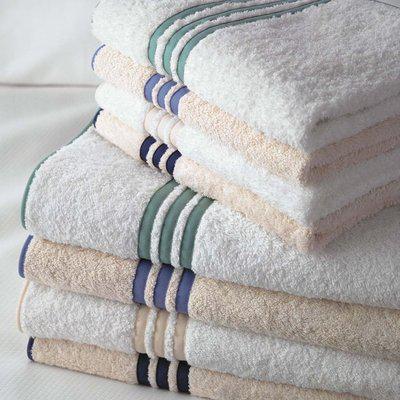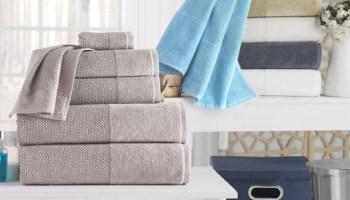The first image is the image on the left, the second image is the image on the right. Given the left and right images, does the statement "There are towels hanging on racks." hold true? Answer yes or no. No. The first image is the image on the left, the second image is the image on the right. Examine the images to the left and right. Is the description "A light colored towel is draped over the side of a freestanding tub." accurate? Answer yes or no. No. 